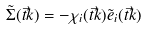<formula> <loc_0><loc_0><loc_500><loc_500>\tilde { \Sigma } ( \vec { t } { k } ) = - \chi _ { i } ( \vec { t } { k } ) \tilde { e } _ { i } ( \vec { t } { k } )</formula> 